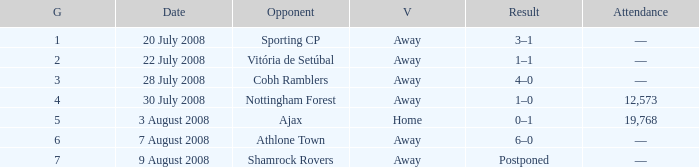What is the lowest game number on 20 July 2008? 1.0. 